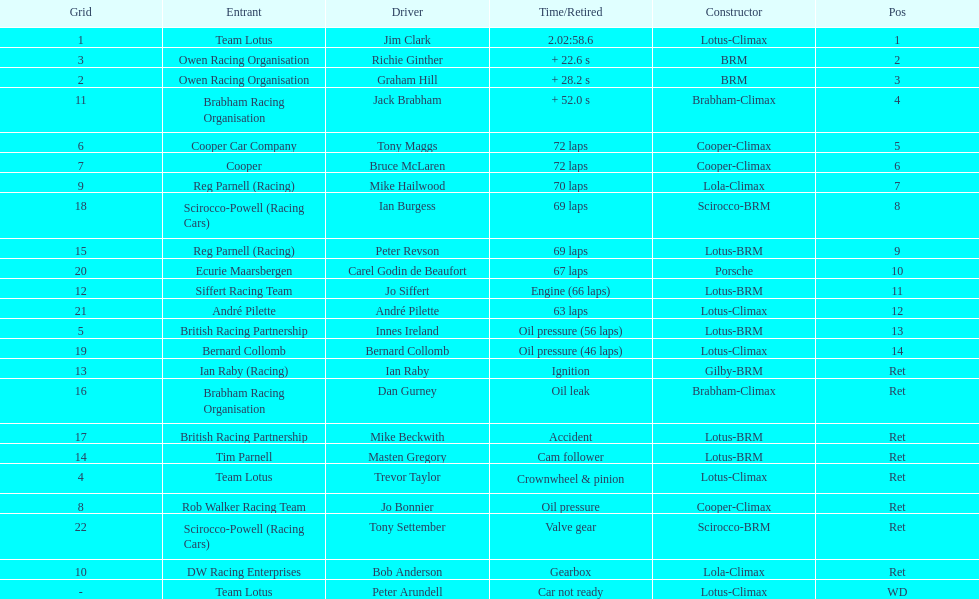Who was the top finisher that drove a cooper-climax? Tony Maggs. 